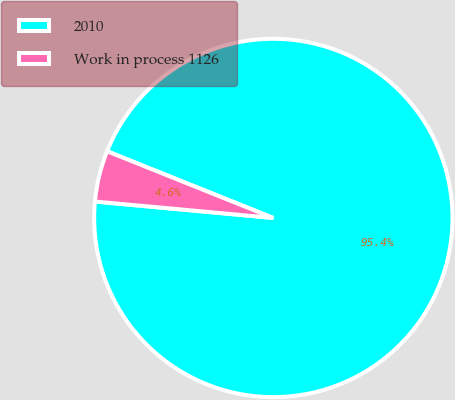Convert chart. <chart><loc_0><loc_0><loc_500><loc_500><pie_chart><fcel>2010<fcel>Work in process 1126<nl><fcel>95.39%<fcel>4.61%<nl></chart> 